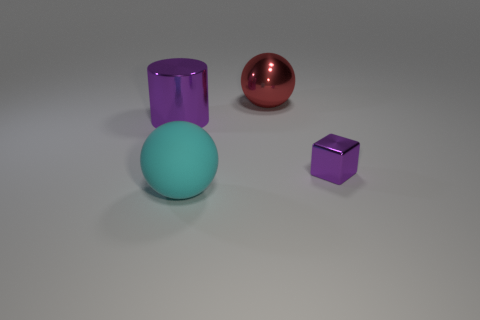Is there anything else that is made of the same material as the large cyan ball?
Keep it short and to the point. No. Is there anything else that is the same size as the shiny block?
Make the answer very short. No. What shape is the thing behind the metallic cylinder that is to the left of the big red metal thing?
Provide a succinct answer. Sphere. Is there any other thing that is the same shape as the tiny metallic object?
Offer a terse response. No. Are there an equal number of red things that are left of the big cyan matte ball and large green matte cylinders?
Keep it short and to the point. Yes. Does the large shiny cylinder have the same color as the shiny thing on the right side of the shiny sphere?
Your answer should be very brief. Yes. There is a metallic object that is on the right side of the matte sphere and in front of the red metallic thing; what color is it?
Make the answer very short. Purple. How many matte balls are behind the purple shiny thing behind the purple block?
Give a very brief answer. 0. Is there a large red metallic thing that has the same shape as the big matte object?
Keep it short and to the point. Yes. Does the purple shiny object left of the large matte thing have the same shape as the purple metallic object that is to the right of the purple metal cylinder?
Provide a succinct answer. No. 